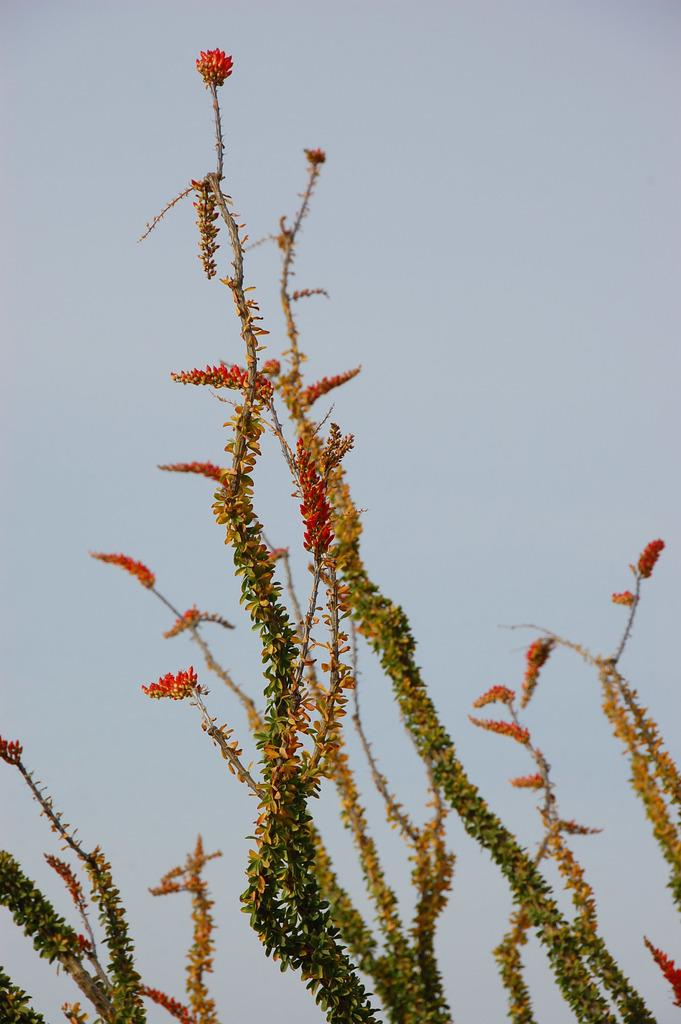What is present in the picture? There is a plant in the picture. What can be observed about the plant? The plant has flowers on it. How many people are in the crowd surrounding the plant in the image? There is no crowd present in the image; it only features a plant with flowers. What color are the eyes of the plant in the image? Plants do not have eyes, so this detail cannot be observed in the image. 